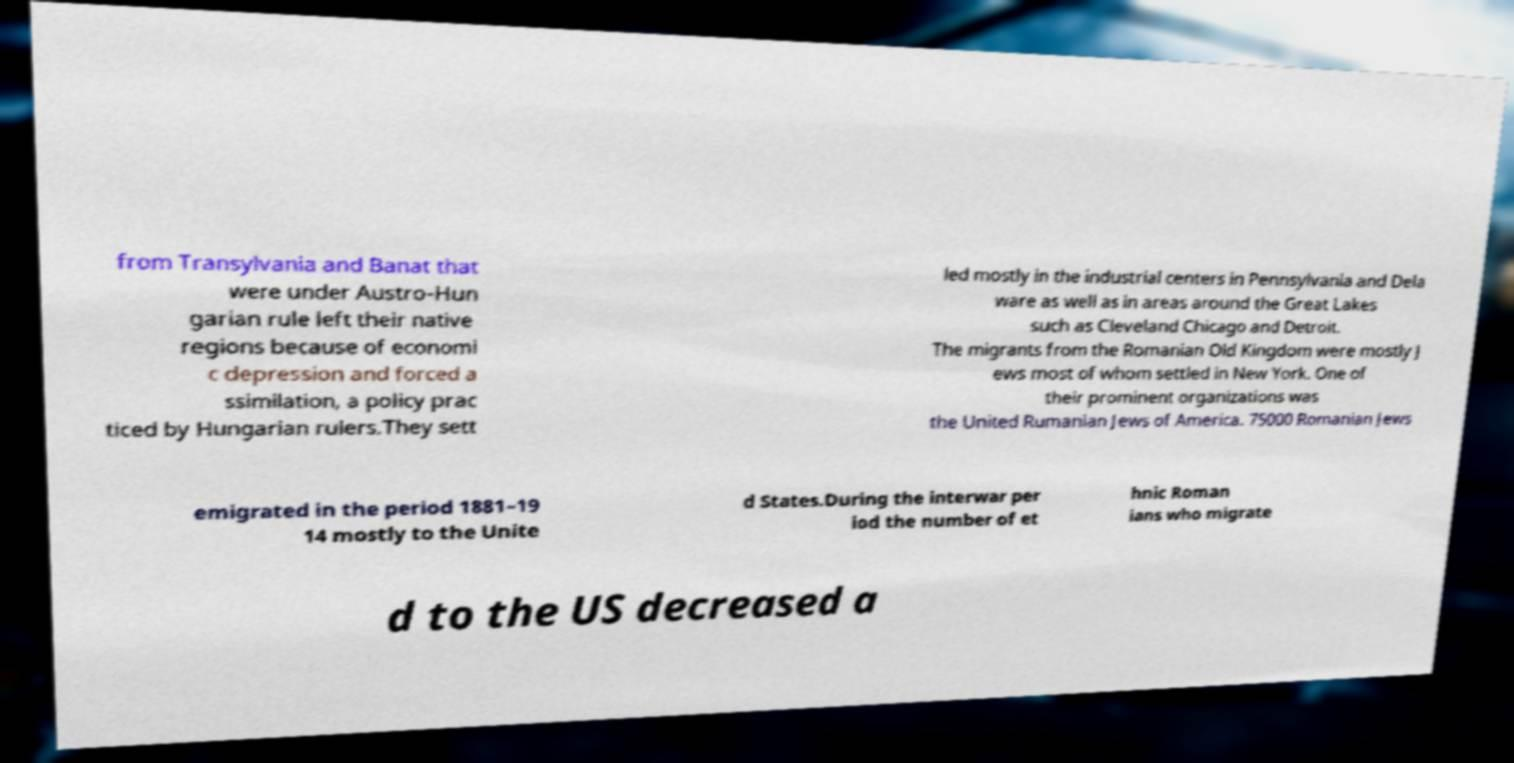For documentation purposes, I need the text within this image transcribed. Could you provide that? from Transylvania and Banat that were under Austro-Hun garian rule left their native regions because of economi c depression and forced a ssimilation, a policy prac ticed by Hungarian rulers.They sett led mostly in the industrial centers in Pennsylvania and Dela ware as well as in areas around the Great Lakes such as Cleveland Chicago and Detroit. The migrants from the Romanian Old Kingdom were mostly J ews most of whom settled in New York. One of their prominent organizations was the United Rumanian Jews of America. 75000 Romanian Jews emigrated in the period 1881–19 14 mostly to the Unite d States.During the interwar per iod the number of et hnic Roman ians who migrate d to the US decreased a 